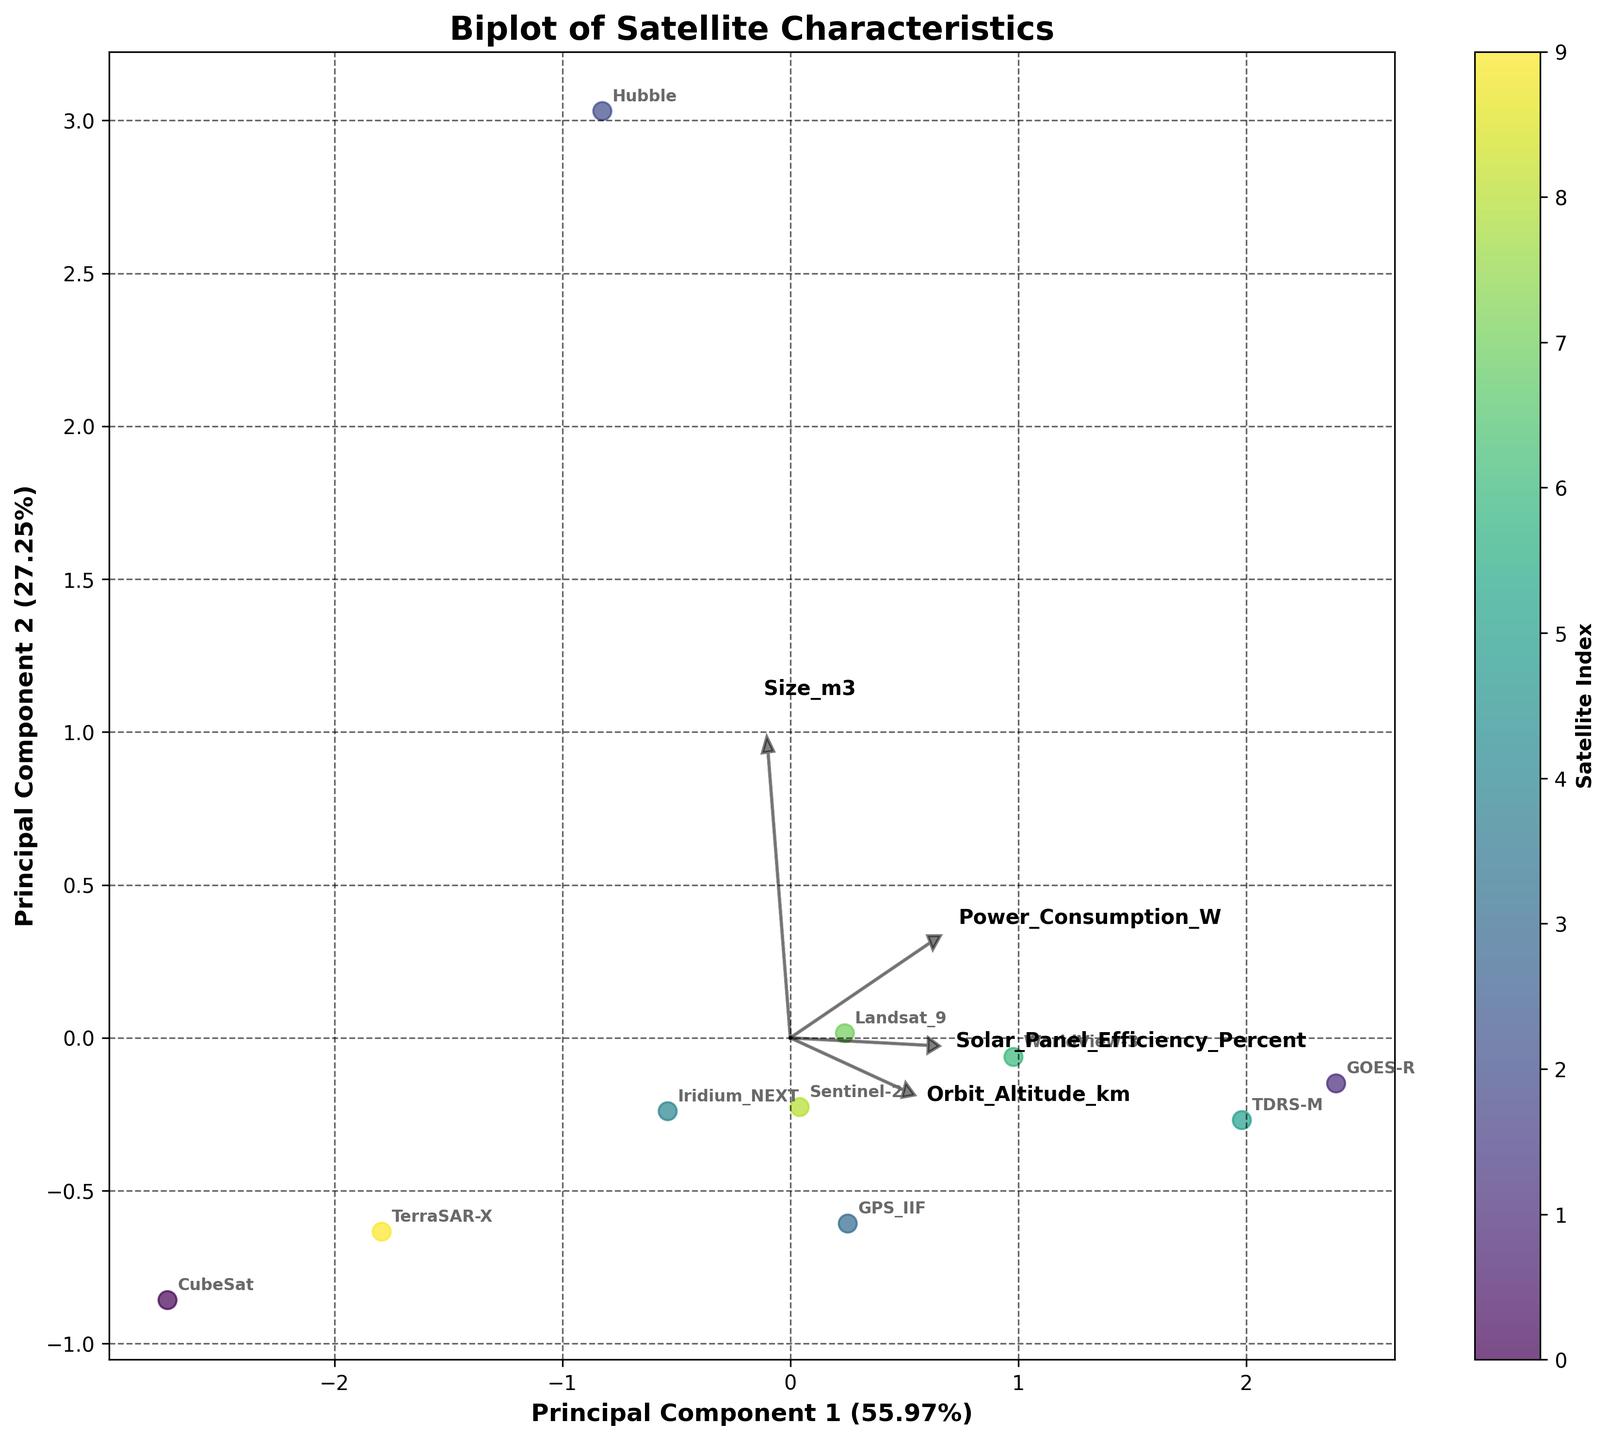what is the title of the plot? The title is typically displayed at the top of the plot. In this case, it is "Biplot of Satellite Characteristics".
Answer: Biplot of Satellite Characteristics how many data points are plotted in the figure? Each data point represents a satellite's characteristics; counting these gives us the number of points. The figure should have 10 data points, as there are 10 satellites listed in the dataset.
Answer: 10 which feature vector points more upwards (towards the positive y-axis)? By looking at the vectors originating from the origin, the feature vector pointing more upwards would be the one with a larger positive y-component. In this case, "Orbit_Altitude_km" points more towards the positive y-axis compared to others.
Answer: Orbit_Altitude_km which principal component explains more variance in the dataset? The principal component with a higher explained variance ratio shown on its axis label explains more variance. Principal Component 1 has a higher percentage of explained variance than Principal Component 2.
Answer: Principal Component 1 which satellite has the highest Power Consumption Watts? On the plot, looking at the position and annotation of satellites, the satellite furthest in the direction of the vector representing `Power_Consumption_W` will have the highest value. GOES-R appears to be furthest in that direction.
Answer: GOES-R how does the size of CubeSat compare to other satellites? CubeSat will be positioned closest to the origin along the `Size_m3` vector since it has the smallest value (0.001 m3) among all satellites.
Answer: It's the smallest do satellites with higher solar panel efficiency tend to have higher or lower orbit altitudes? By examining the biplot, you would see if there is a trend along the `Solar_Panel_Efficiency_Percent` vector. Satellites with higher solar efficiency ('more positive' on that vector) will need to be compared with their position on the `Orbit_Altitude_km` vector. It appears that the higher efficiency ones like WorldView-3 and TDRS-M have varied altitudes, so no clear trend is indicated.
Answer: No clear trend indicated which two satellites are most similar in their characteristics based on their positions in the biplot? The satellites closest to each other in the space defined by the first two principal components are most similar. For instance, Landsat 9 and Sentinel-2 are quite close to each other in the plot.
Answer: Landsat 9 and Sentinel-2 which feature seems to have the smallest effect on the first principal component? The smallest effect corresponds to the smallest absolute value of the vector's component along the first principal component’s axis. By examining the vectors, `Size_m3` appears to have the least impact on the first principal component.
Answer: Size_m3 